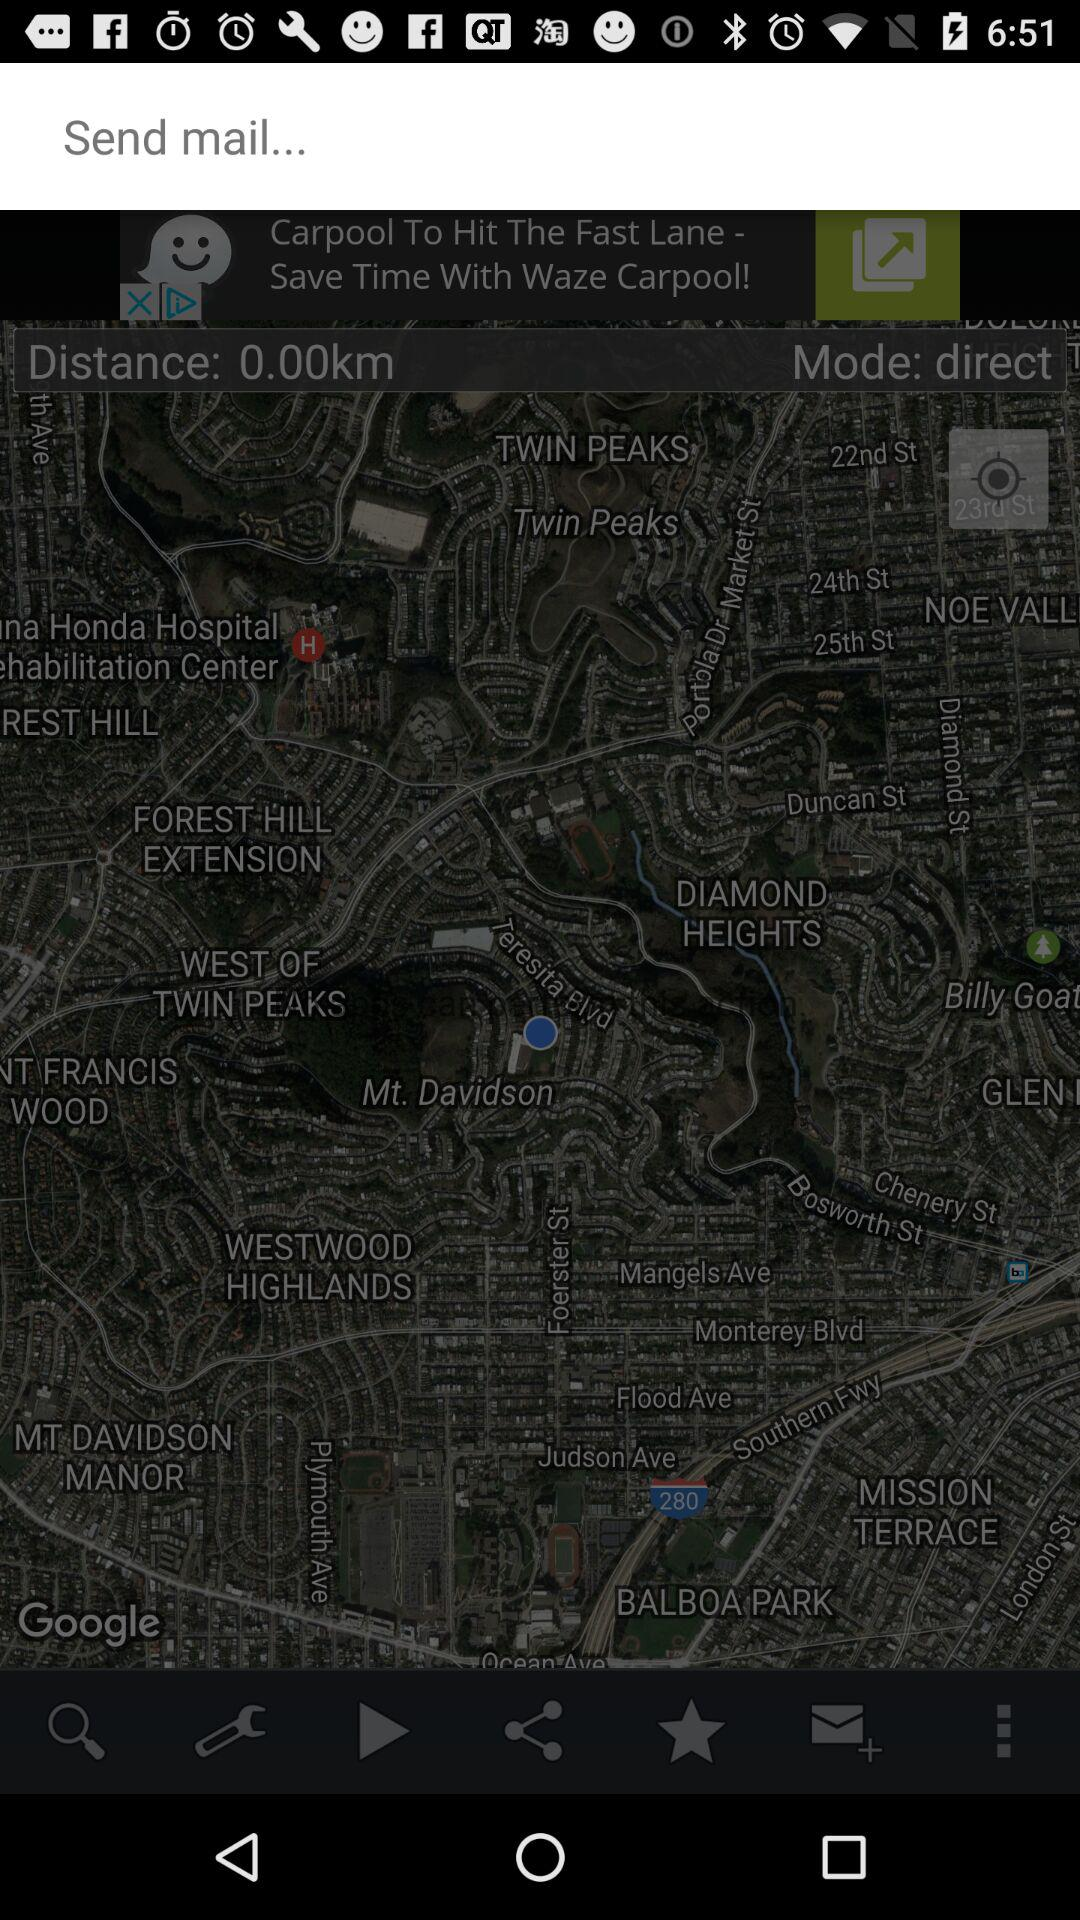What is the mode? The mode is direct. 